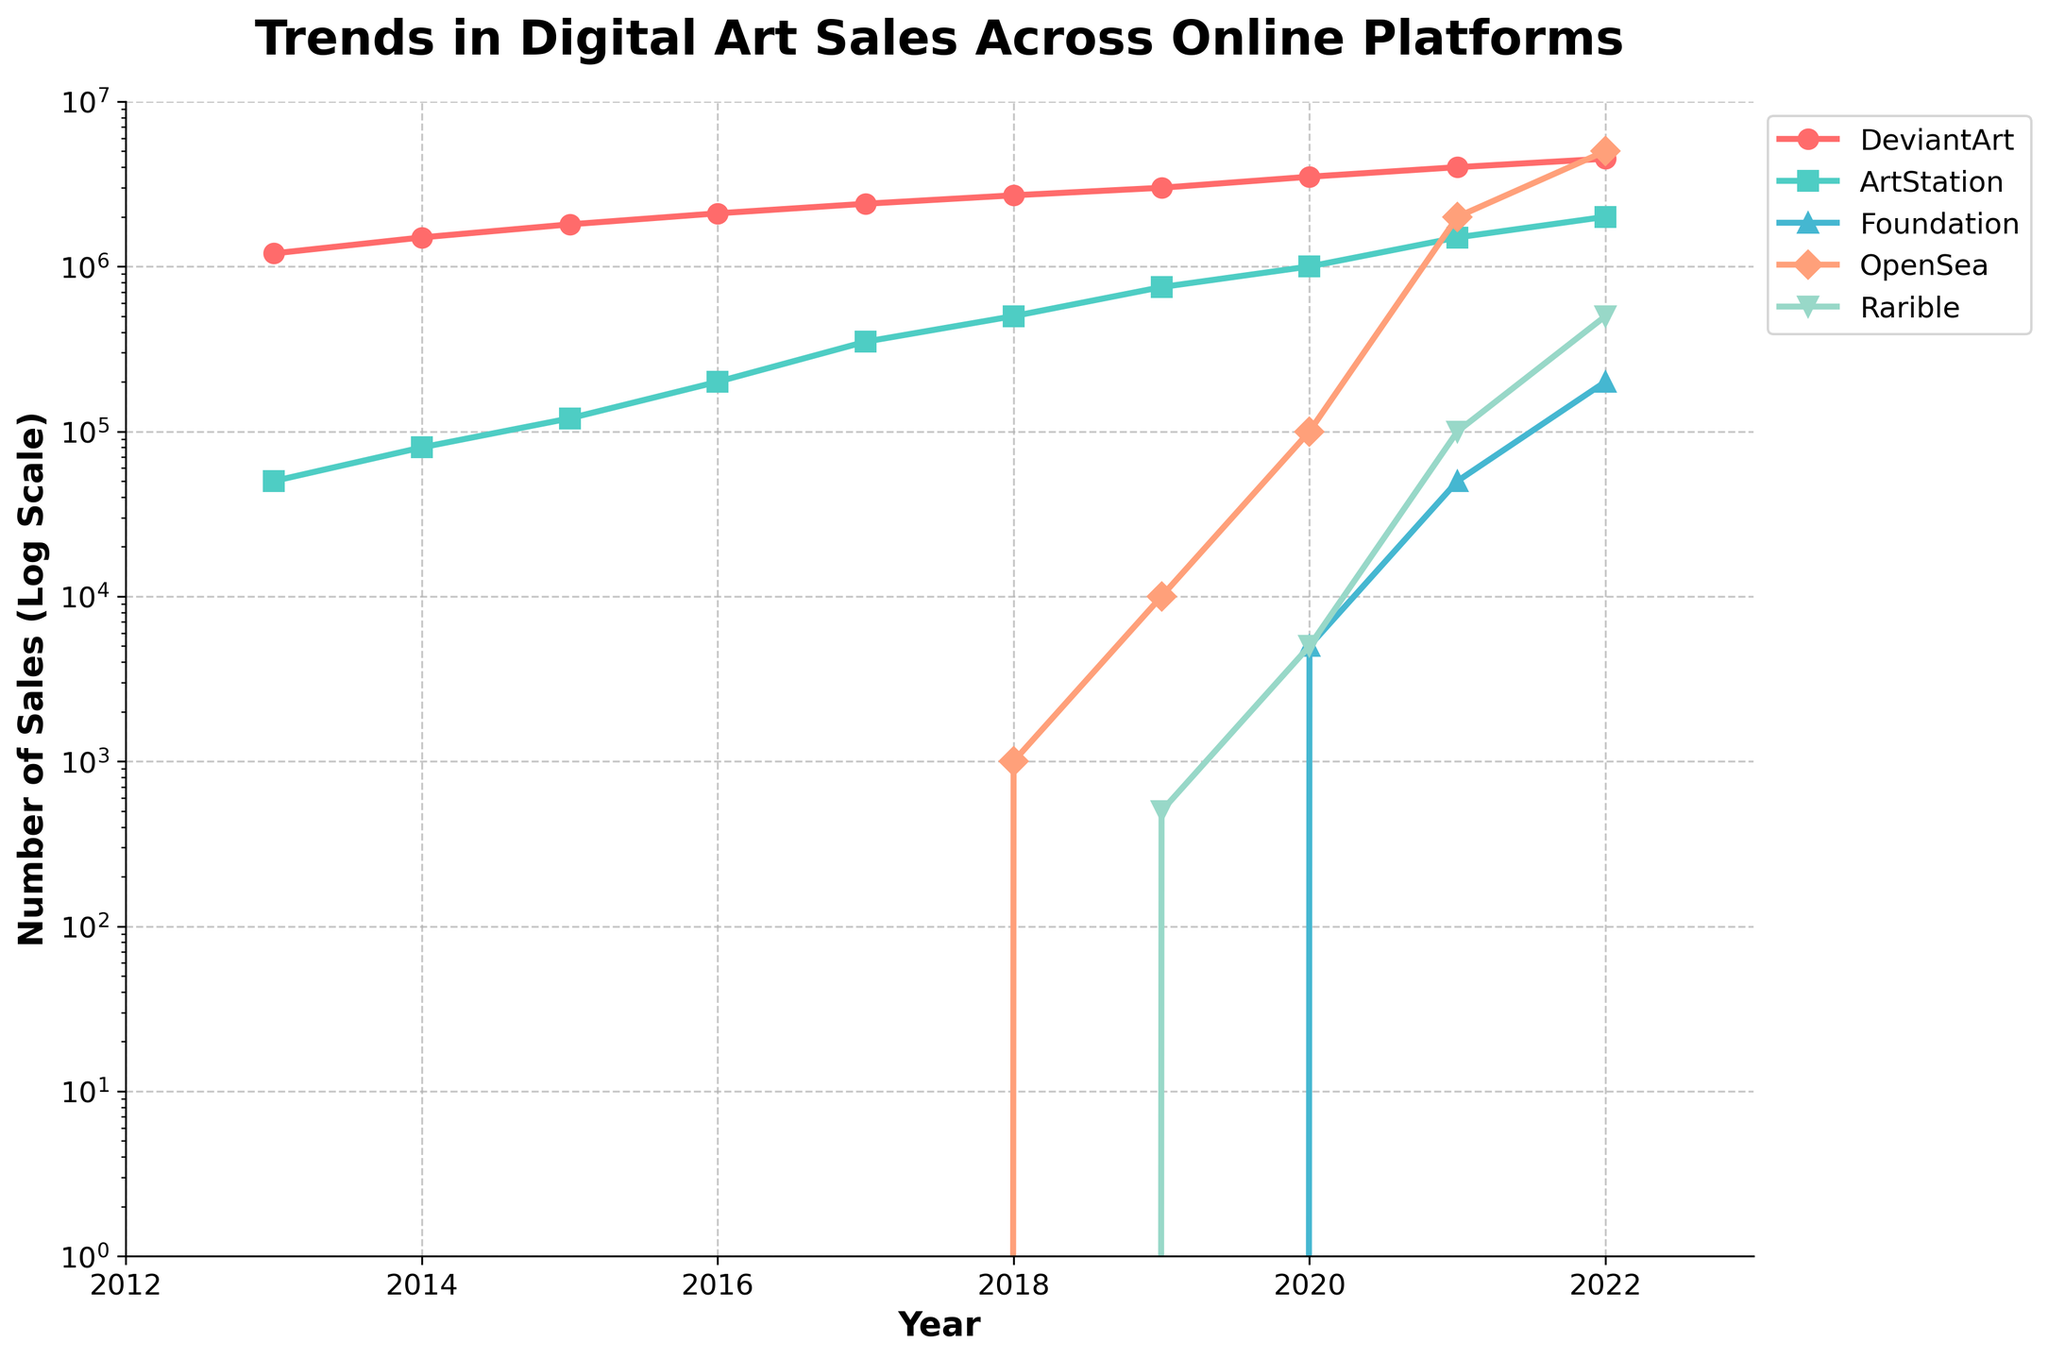What's the trend in sales volume for DeviantArt over the past decade? By observing the plot, the sales on DeviantArt have a consistent upward trajectory from 2013 (1,200,000) to 2022 (4,500,000).
Answer: Increasing Which platform had the most dramatic increase in sales from 2020 to 2021? Looking at the plot, OpenSea's sales surged from 100,000 in 2020 to 2,000,000 in 2021, exhibiting the most dramatic annual increase.
Answer: OpenSea Between ArtStation and Foundation, which platform had a higher sales volume in 2022, and by how much? In 2022, ArtStation had 2,000,000 sales, while Foundation had 200,000. The difference is 2,000,000 - 200,000 = 1,800,000.
Answer: ArtStation by 1,800,000 For which year(s) did Rarible experience a sales volume of at least 100,000? Rarible's sales reached 100,000 or more only in 2021 (100,000) and 2022 (500,000), as seen on the plot.
Answer: 2021, 2022 Looking at the sales volume trend from 2013 to 2022, did any platform other than OpenSea and Rarible have exponential growth patterns? DeviantArt and ArtStation both show a consistent but not exponential growth, whereas Foundation and Rarible exhibit a rapid increase pattern towards the past few years, particularly noticeable in OpenSea's spike.
Answer: No, only OpenSea and Rarible How did the sales volume of OpenSea compare to Foundation in 2021? In 2021, OpenSea had a significantly higher sales volume of 2,000,000 compared to Foundation's 50,000.
Answer: OpenSea significantly higher At what point do OpenSea's sales volumes surpass those of DeviantArt? OpenSea surpasses DeviantArt's sales in 2022. OpenSea had 5,000,000 sales compared to DeviantArt's 4,500,000 that year.
Answer: 2022 Which platform shows the smallest variation in sales across the entire decade? DeviantArt consistently grows, but the plot shows it without dramatic peaks or drops, suggesting a relatively smaller variation compared to others like OpenSea or ArtStation.
Answer: DeviantArt What was the average sales volume of ArtStation from 2013 to 2022? Summing up ArtStation's sales (50,000 + 80,000 + 120,000 + 200,000 + 350,000 + 500,000 + 750,000 + 1,000,000 + 1,500,000 + 2,000,000) yields 6,550,000 sales. The average for these 10 years is 6,550,000 / 10 = 655,000.
Answer: 655,000 